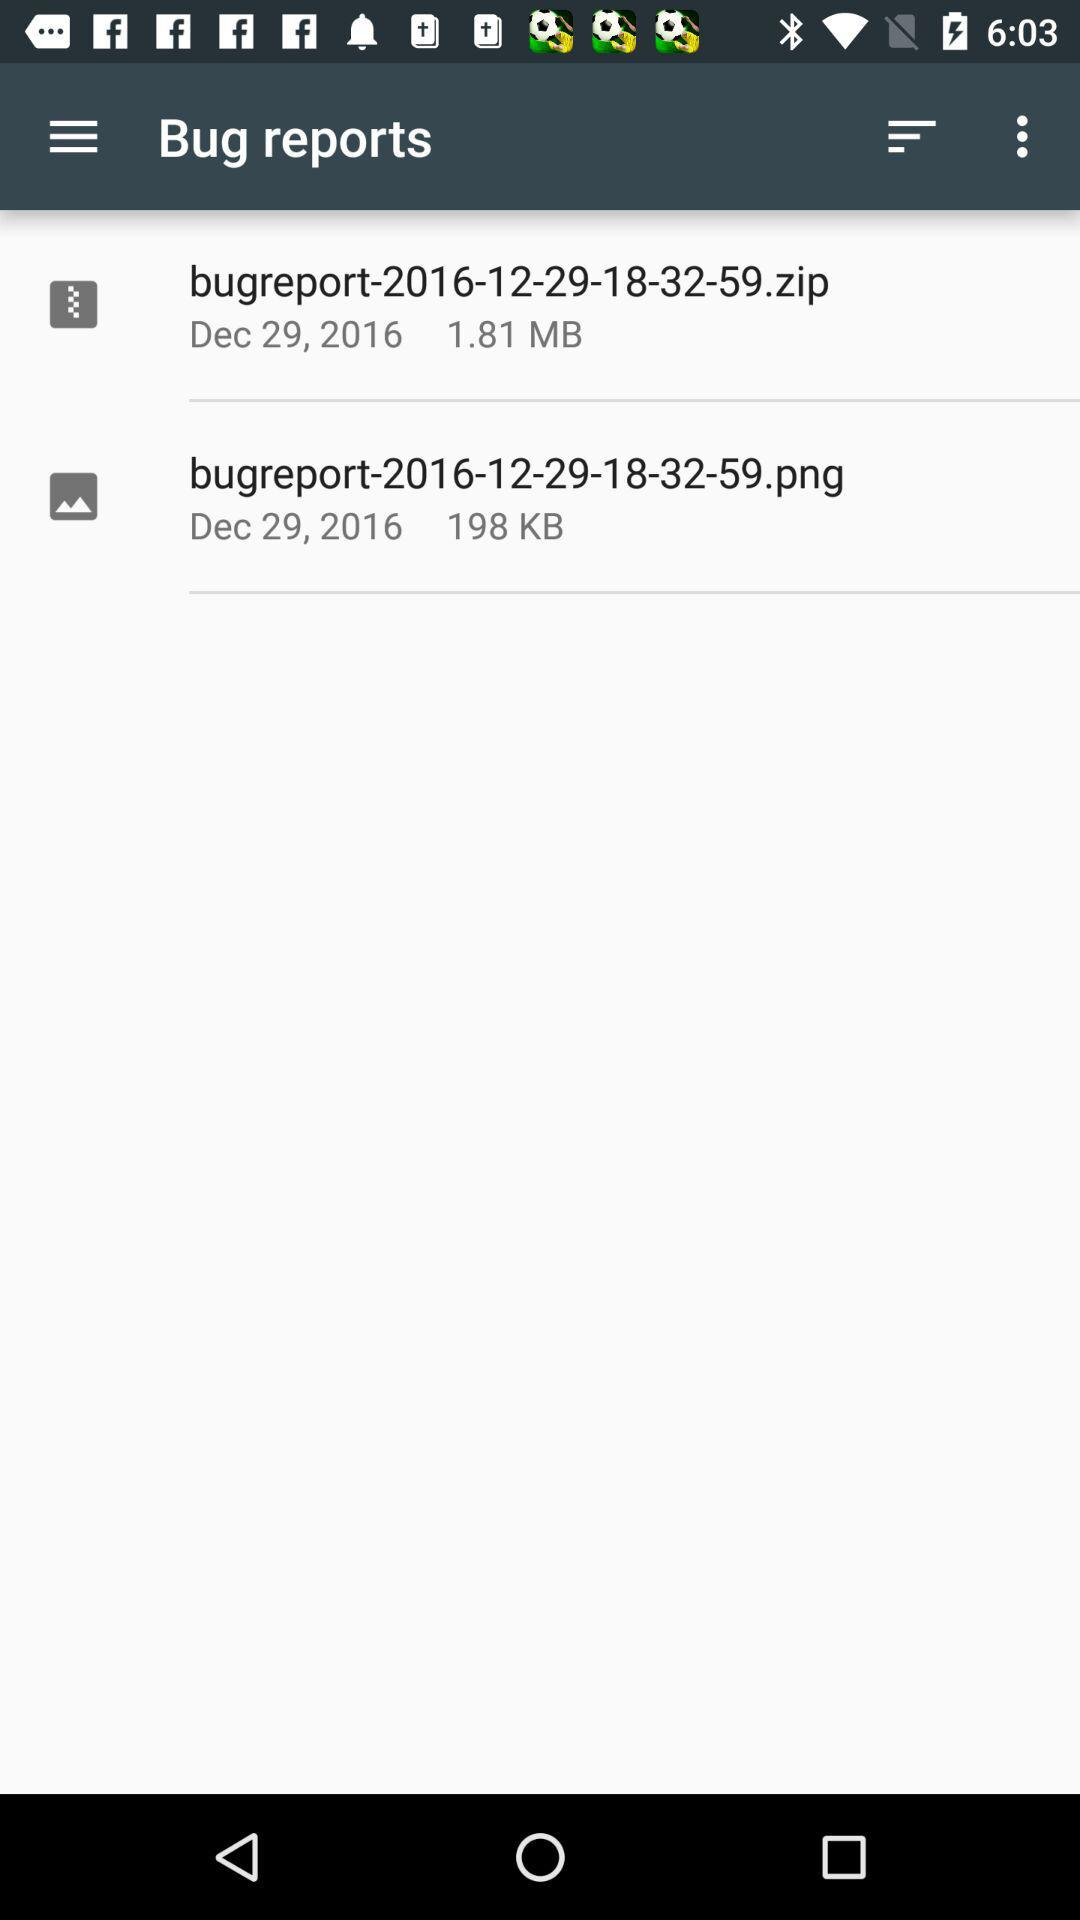What date is mentioned in "Bug Reports"? The mentioned date in "Bug Reports" is December 29, 2016. 